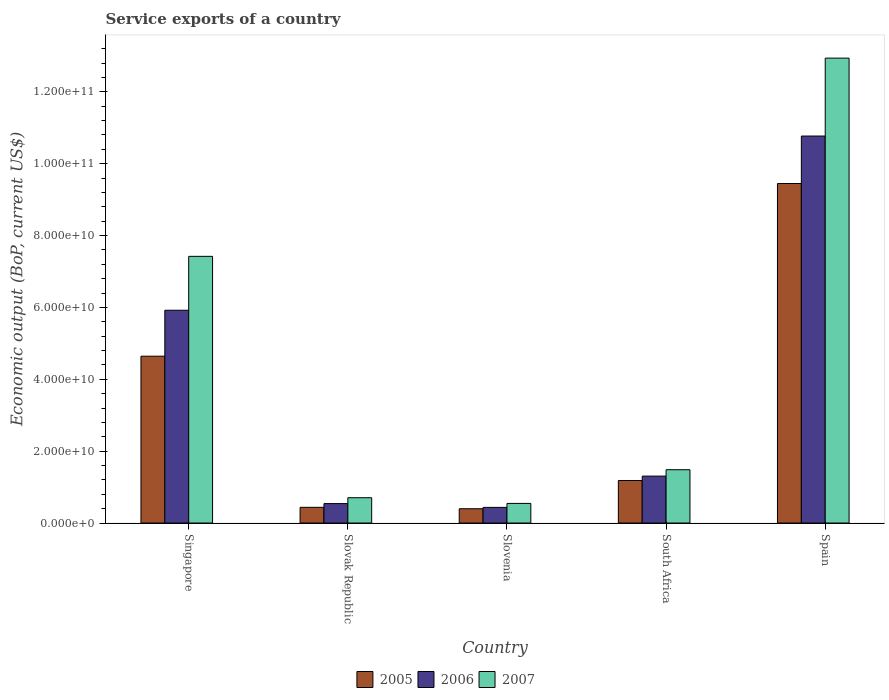How many groups of bars are there?
Provide a short and direct response. 5. Are the number of bars per tick equal to the number of legend labels?
Ensure brevity in your answer.  Yes. How many bars are there on the 5th tick from the left?
Your answer should be compact. 3. How many bars are there on the 1st tick from the right?
Provide a short and direct response. 3. What is the label of the 1st group of bars from the left?
Your response must be concise. Singapore. What is the service exports in 2005 in Slovak Republic?
Your answer should be very brief. 4.37e+09. Across all countries, what is the maximum service exports in 2007?
Make the answer very short. 1.29e+11. Across all countries, what is the minimum service exports in 2007?
Offer a terse response. 5.46e+09. In which country was the service exports in 2007 minimum?
Your answer should be compact. Slovenia. What is the total service exports in 2005 in the graph?
Your answer should be compact. 1.61e+11. What is the difference between the service exports in 2006 in Singapore and that in Slovak Republic?
Ensure brevity in your answer.  5.38e+1. What is the difference between the service exports in 2006 in Slovenia and the service exports in 2005 in Slovak Republic?
Your response must be concise. -1.58e+07. What is the average service exports in 2007 per country?
Offer a very short reply. 4.62e+1. What is the difference between the service exports of/in 2005 and service exports of/in 2007 in Slovak Republic?
Your response must be concise. -2.67e+09. What is the ratio of the service exports in 2007 in Singapore to that in South Africa?
Offer a terse response. 5. Is the service exports in 2005 in Slovak Republic less than that in South Africa?
Ensure brevity in your answer.  Yes. Is the difference between the service exports in 2005 in Slovak Republic and Slovenia greater than the difference between the service exports in 2007 in Slovak Republic and Slovenia?
Make the answer very short. No. What is the difference between the highest and the second highest service exports in 2007?
Provide a short and direct response. 5.52e+1. What is the difference between the highest and the lowest service exports in 2006?
Your answer should be very brief. 1.03e+11. Is the sum of the service exports in 2006 in Singapore and Slovenia greater than the maximum service exports in 2007 across all countries?
Your answer should be compact. No. What does the 3rd bar from the right in Singapore represents?
Provide a succinct answer. 2005. Is it the case that in every country, the sum of the service exports in 2005 and service exports in 2007 is greater than the service exports in 2006?
Ensure brevity in your answer.  Yes. Are all the bars in the graph horizontal?
Your response must be concise. No. How many countries are there in the graph?
Your answer should be very brief. 5. What is the difference between two consecutive major ticks on the Y-axis?
Give a very brief answer. 2.00e+1. Are the values on the major ticks of Y-axis written in scientific E-notation?
Offer a very short reply. Yes. Does the graph contain any zero values?
Give a very brief answer. No. How many legend labels are there?
Your answer should be very brief. 3. What is the title of the graph?
Offer a very short reply. Service exports of a country. What is the label or title of the Y-axis?
Your response must be concise. Economic output (BoP, current US$). What is the Economic output (BoP, current US$) of 2005 in Singapore?
Make the answer very short. 4.64e+1. What is the Economic output (BoP, current US$) of 2006 in Singapore?
Offer a very short reply. 5.92e+1. What is the Economic output (BoP, current US$) in 2007 in Singapore?
Your answer should be compact. 7.42e+1. What is the Economic output (BoP, current US$) of 2005 in Slovak Republic?
Your answer should be very brief. 4.37e+09. What is the Economic output (BoP, current US$) of 2006 in Slovak Republic?
Provide a short and direct response. 5.41e+09. What is the Economic output (BoP, current US$) of 2007 in Slovak Republic?
Provide a short and direct response. 7.04e+09. What is the Economic output (BoP, current US$) of 2005 in Slovenia?
Offer a terse response. 3.98e+09. What is the Economic output (BoP, current US$) in 2006 in Slovenia?
Offer a terse response. 4.36e+09. What is the Economic output (BoP, current US$) in 2007 in Slovenia?
Make the answer very short. 5.46e+09. What is the Economic output (BoP, current US$) in 2005 in South Africa?
Ensure brevity in your answer.  1.18e+1. What is the Economic output (BoP, current US$) of 2006 in South Africa?
Offer a very short reply. 1.31e+1. What is the Economic output (BoP, current US$) in 2007 in South Africa?
Give a very brief answer. 1.48e+1. What is the Economic output (BoP, current US$) of 2005 in Spain?
Provide a succinct answer. 9.45e+1. What is the Economic output (BoP, current US$) of 2006 in Spain?
Provide a succinct answer. 1.08e+11. What is the Economic output (BoP, current US$) of 2007 in Spain?
Your answer should be compact. 1.29e+11. Across all countries, what is the maximum Economic output (BoP, current US$) of 2005?
Make the answer very short. 9.45e+1. Across all countries, what is the maximum Economic output (BoP, current US$) in 2006?
Ensure brevity in your answer.  1.08e+11. Across all countries, what is the maximum Economic output (BoP, current US$) of 2007?
Your answer should be very brief. 1.29e+11. Across all countries, what is the minimum Economic output (BoP, current US$) of 2005?
Make the answer very short. 3.98e+09. Across all countries, what is the minimum Economic output (BoP, current US$) of 2006?
Ensure brevity in your answer.  4.36e+09. Across all countries, what is the minimum Economic output (BoP, current US$) in 2007?
Make the answer very short. 5.46e+09. What is the total Economic output (BoP, current US$) of 2005 in the graph?
Your answer should be compact. 1.61e+11. What is the total Economic output (BoP, current US$) in 2006 in the graph?
Offer a terse response. 1.90e+11. What is the total Economic output (BoP, current US$) of 2007 in the graph?
Provide a succinct answer. 2.31e+11. What is the difference between the Economic output (BoP, current US$) in 2005 in Singapore and that in Slovak Republic?
Your response must be concise. 4.21e+1. What is the difference between the Economic output (BoP, current US$) in 2006 in Singapore and that in Slovak Republic?
Make the answer very short. 5.38e+1. What is the difference between the Economic output (BoP, current US$) of 2007 in Singapore and that in Slovak Republic?
Offer a terse response. 6.72e+1. What is the difference between the Economic output (BoP, current US$) in 2005 in Singapore and that in Slovenia?
Your answer should be compact. 4.25e+1. What is the difference between the Economic output (BoP, current US$) of 2006 in Singapore and that in Slovenia?
Your answer should be compact. 5.49e+1. What is the difference between the Economic output (BoP, current US$) of 2007 in Singapore and that in Slovenia?
Your answer should be compact. 6.88e+1. What is the difference between the Economic output (BoP, current US$) of 2005 in Singapore and that in South Africa?
Offer a terse response. 3.46e+1. What is the difference between the Economic output (BoP, current US$) in 2006 in Singapore and that in South Africa?
Ensure brevity in your answer.  4.62e+1. What is the difference between the Economic output (BoP, current US$) in 2007 in Singapore and that in South Africa?
Offer a terse response. 5.94e+1. What is the difference between the Economic output (BoP, current US$) of 2005 in Singapore and that in Spain?
Offer a terse response. -4.81e+1. What is the difference between the Economic output (BoP, current US$) of 2006 in Singapore and that in Spain?
Give a very brief answer. -4.85e+1. What is the difference between the Economic output (BoP, current US$) in 2007 in Singapore and that in Spain?
Offer a very short reply. -5.52e+1. What is the difference between the Economic output (BoP, current US$) in 2005 in Slovak Republic and that in Slovenia?
Keep it short and to the point. 3.96e+08. What is the difference between the Economic output (BoP, current US$) in 2006 in Slovak Republic and that in Slovenia?
Offer a very short reply. 1.06e+09. What is the difference between the Economic output (BoP, current US$) of 2007 in Slovak Republic and that in Slovenia?
Make the answer very short. 1.59e+09. What is the difference between the Economic output (BoP, current US$) in 2005 in Slovak Republic and that in South Africa?
Keep it short and to the point. -7.46e+09. What is the difference between the Economic output (BoP, current US$) of 2006 in Slovak Republic and that in South Africa?
Give a very brief answer. -7.65e+09. What is the difference between the Economic output (BoP, current US$) of 2007 in Slovak Republic and that in South Africa?
Your response must be concise. -7.79e+09. What is the difference between the Economic output (BoP, current US$) in 2005 in Slovak Republic and that in Spain?
Offer a very short reply. -9.01e+1. What is the difference between the Economic output (BoP, current US$) of 2006 in Slovak Republic and that in Spain?
Make the answer very short. -1.02e+11. What is the difference between the Economic output (BoP, current US$) of 2007 in Slovak Republic and that in Spain?
Your answer should be compact. -1.22e+11. What is the difference between the Economic output (BoP, current US$) of 2005 in Slovenia and that in South Africa?
Provide a short and direct response. -7.85e+09. What is the difference between the Economic output (BoP, current US$) in 2006 in Slovenia and that in South Africa?
Your answer should be compact. -8.70e+09. What is the difference between the Economic output (BoP, current US$) of 2007 in Slovenia and that in South Africa?
Provide a succinct answer. -9.38e+09. What is the difference between the Economic output (BoP, current US$) in 2005 in Slovenia and that in Spain?
Your response must be concise. -9.05e+1. What is the difference between the Economic output (BoP, current US$) of 2006 in Slovenia and that in Spain?
Your response must be concise. -1.03e+11. What is the difference between the Economic output (BoP, current US$) in 2007 in Slovenia and that in Spain?
Your answer should be very brief. -1.24e+11. What is the difference between the Economic output (BoP, current US$) in 2005 in South Africa and that in Spain?
Offer a terse response. -8.27e+1. What is the difference between the Economic output (BoP, current US$) in 2006 in South Africa and that in Spain?
Offer a terse response. -9.46e+1. What is the difference between the Economic output (BoP, current US$) of 2007 in South Africa and that in Spain?
Your answer should be compact. -1.15e+11. What is the difference between the Economic output (BoP, current US$) of 2005 in Singapore and the Economic output (BoP, current US$) of 2006 in Slovak Republic?
Give a very brief answer. 4.10e+1. What is the difference between the Economic output (BoP, current US$) in 2005 in Singapore and the Economic output (BoP, current US$) in 2007 in Slovak Republic?
Make the answer very short. 3.94e+1. What is the difference between the Economic output (BoP, current US$) of 2006 in Singapore and the Economic output (BoP, current US$) of 2007 in Slovak Republic?
Ensure brevity in your answer.  5.22e+1. What is the difference between the Economic output (BoP, current US$) in 2005 in Singapore and the Economic output (BoP, current US$) in 2006 in Slovenia?
Provide a short and direct response. 4.21e+1. What is the difference between the Economic output (BoP, current US$) in 2005 in Singapore and the Economic output (BoP, current US$) in 2007 in Slovenia?
Offer a terse response. 4.10e+1. What is the difference between the Economic output (BoP, current US$) in 2006 in Singapore and the Economic output (BoP, current US$) in 2007 in Slovenia?
Provide a succinct answer. 5.38e+1. What is the difference between the Economic output (BoP, current US$) in 2005 in Singapore and the Economic output (BoP, current US$) in 2006 in South Africa?
Provide a succinct answer. 3.34e+1. What is the difference between the Economic output (BoP, current US$) in 2005 in Singapore and the Economic output (BoP, current US$) in 2007 in South Africa?
Make the answer very short. 3.16e+1. What is the difference between the Economic output (BoP, current US$) of 2006 in Singapore and the Economic output (BoP, current US$) of 2007 in South Africa?
Your response must be concise. 4.44e+1. What is the difference between the Economic output (BoP, current US$) in 2005 in Singapore and the Economic output (BoP, current US$) in 2006 in Spain?
Your response must be concise. -6.13e+1. What is the difference between the Economic output (BoP, current US$) in 2005 in Singapore and the Economic output (BoP, current US$) in 2007 in Spain?
Keep it short and to the point. -8.30e+1. What is the difference between the Economic output (BoP, current US$) of 2006 in Singapore and the Economic output (BoP, current US$) of 2007 in Spain?
Give a very brief answer. -7.02e+1. What is the difference between the Economic output (BoP, current US$) in 2005 in Slovak Republic and the Economic output (BoP, current US$) in 2006 in Slovenia?
Your answer should be compact. 1.58e+07. What is the difference between the Economic output (BoP, current US$) of 2005 in Slovak Republic and the Economic output (BoP, current US$) of 2007 in Slovenia?
Give a very brief answer. -1.09e+09. What is the difference between the Economic output (BoP, current US$) of 2006 in Slovak Republic and the Economic output (BoP, current US$) of 2007 in Slovenia?
Make the answer very short. -4.57e+07. What is the difference between the Economic output (BoP, current US$) of 2005 in Slovak Republic and the Economic output (BoP, current US$) of 2006 in South Africa?
Your answer should be compact. -8.69e+09. What is the difference between the Economic output (BoP, current US$) in 2005 in Slovak Republic and the Economic output (BoP, current US$) in 2007 in South Africa?
Offer a very short reply. -1.05e+1. What is the difference between the Economic output (BoP, current US$) in 2006 in Slovak Republic and the Economic output (BoP, current US$) in 2007 in South Africa?
Give a very brief answer. -9.43e+09. What is the difference between the Economic output (BoP, current US$) of 2005 in Slovak Republic and the Economic output (BoP, current US$) of 2006 in Spain?
Keep it short and to the point. -1.03e+11. What is the difference between the Economic output (BoP, current US$) of 2005 in Slovak Republic and the Economic output (BoP, current US$) of 2007 in Spain?
Offer a very short reply. -1.25e+11. What is the difference between the Economic output (BoP, current US$) of 2006 in Slovak Republic and the Economic output (BoP, current US$) of 2007 in Spain?
Your response must be concise. -1.24e+11. What is the difference between the Economic output (BoP, current US$) in 2005 in Slovenia and the Economic output (BoP, current US$) in 2006 in South Africa?
Ensure brevity in your answer.  -9.08e+09. What is the difference between the Economic output (BoP, current US$) of 2005 in Slovenia and the Economic output (BoP, current US$) of 2007 in South Africa?
Your response must be concise. -1.09e+1. What is the difference between the Economic output (BoP, current US$) in 2006 in Slovenia and the Economic output (BoP, current US$) in 2007 in South Africa?
Provide a short and direct response. -1.05e+1. What is the difference between the Economic output (BoP, current US$) of 2005 in Slovenia and the Economic output (BoP, current US$) of 2006 in Spain?
Provide a short and direct response. -1.04e+11. What is the difference between the Economic output (BoP, current US$) in 2005 in Slovenia and the Economic output (BoP, current US$) in 2007 in Spain?
Your answer should be very brief. -1.25e+11. What is the difference between the Economic output (BoP, current US$) of 2006 in Slovenia and the Economic output (BoP, current US$) of 2007 in Spain?
Ensure brevity in your answer.  -1.25e+11. What is the difference between the Economic output (BoP, current US$) of 2005 in South Africa and the Economic output (BoP, current US$) of 2006 in Spain?
Your answer should be very brief. -9.59e+1. What is the difference between the Economic output (BoP, current US$) in 2005 in South Africa and the Economic output (BoP, current US$) in 2007 in Spain?
Your response must be concise. -1.18e+11. What is the difference between the Economic output (BoP, current US$) in 2006 in South Africa and the Economic output (BoP, current US$) in 2007 in Spain?
Your answer should be compact. -1.16e+11. What is the average Economic output (BoP, current US$) of 2005 per country?
Provide a short and direct response. 3.22e+1. What is the average Economic output (BoP, current US$) of 2006 per country?
Make the answer very short. 3.79e+1. What is the average Economic output (BoP, current US$) in 2007 per country?
Offer a very short reply. 4.62e+1. What is the difference between the Economic output (BoP, current US$) of 2005 and Economic output (BoP, current US$) of 2006 in Singapore?
Your answer should be very brief. -1.28e+1. What is the difference between the Economic output (BoP, current US$) in 2005 and Economic output (BoP, current US$) in 2007 in Singapore?
Provide a short and direct response. -2.78e+1. What is the difference between the Economic output (BoP, current US$) of 2006 and Economic output (BoP, current US$) of 2007 in Singapore?
Make the answer very short. -1.50e+1. What is the difference between the Economic output (BoP, current US$) of 2005 and Economic output (BoP, current US$) of 2006 in Slovak Republic?
Make the answer very short. -1.04e+09. What is the difference between the Economic output (BoP, current US$) of 2005 and Economic output (BoP, current US$) of 2007 in Slovak Republic?
Ensure brevity in your answer.  -2.67e+09. What is the difference between the Economic output (BoP, current US$) in 2006 and Economic output (BoP, current US$) in 2007 in Slovak Republic?
Your answer should be very brief. -1.63e+09. What is the difference between the Economic output (BoP, current US$) of 2005 and Economic output (BoP, current US$) of 2006 in Slovenia?
Your answer should be compact. -3.81e+08. What is the difference between the Economic output (BoP, current US$) of 2005 and Economic output (BoP, current US$) of 2007 in Slovenia?
Your answer should be very brief. -1.48e+09. What is the difference between the Economic output (BoP, current US$) in 2006 and Economic output (BoP, current US$) in 2007 in Slovenia?
Your response must be concise. -1.10e+09. What is the difference between the Economic output (BoP, current US$) in 2005 and Economic output (BoP, current US$) in 2006 in South Africa?
Your answer should be compact. -1.23e+09. What is the difference between the Economic output (BoP, current US$) in 2005 and Economic output (BoP, current US$) in 2007 in South Africa?
Your answer should be compact. -3.01e+09. What is the difference between the Economic output (BoP, current US$) in 2006 and Economic output (BoP, current US$) in 2007 in South Africa?
Your answer should be very brief. -1.78e+09. What is the difference between the Economic output (BoP, current US$) of 2005 and Economic output (BoP, current US$) of 2006 in Spain?
Keep it short and to the point. -1.32e+1. What is the difference between the Economic output (BoP, current US$) in 2005 and Economic output (BoP, current US$) in 2007 in Spain?
Provide a succinct answer. -3.49e+1. What is the difference between the Economic output (BoP, current US$) of 2006 and Economic output (BoP, current US$) of 2007 in Spain?
Your answer should be very brief. -2.17e+1. What is the ratio of the Economic output (BoP, current US$) of 2005 in Singapore to that in Slovak Republic?
Your response must be concise. 10.62. What is the ratio of the Economic output (BoP, current US$) of 2006 in Singapore to that in Slovak Republic?
Ensure brevity in your answer.  10.94. What is the ratio of the Economic output (BoP, current US$) of 2007 in Singapore to that in Slovak Republic?
Offer a very short reply. 10.53. What is the ratio of the Economic output (BoP, current US$) in 2005 in Singapore to that in Slovenia?
Provide a succinct answer. 11.68. What is the ratio of the Economic output (BoP, current US$) of 2006 in Singapore to that in Slovenia?
Provide a succinct answer. 13.59. What is the ratio of the Economic output (BoP, current US$) in 2007 in Singapore to that in Slovenia?
Your answer should be compact. 13.6. What is the ratio of the Economic output (BoP, current US$) of 2005 in Singapore to that in South Africa?
Your answer should be compact. 3.92. What is the ratio of the Economic output (BoP, current US$) of 2006 in Singapore to that in South Africa?
Your answer should be compact. 4.53. What is the ratio of the Economic output (BoP, current US$) of 2007 in Singapore to that in South Africa?
Provide a succinct answer. 5. What is the ratio of the Economic output (BoP, current US$) in 2005 in Singapore to that in Spain?
Your response must be concise. 0.49. What is the ratio of the Economic output (BoP, current US$) in 2006 in Singapore to that in Spain?
Give a very brief answer. 0.55. What is the ratio of the Economic output (BoP, current US$) in 2007 in Singapore to that in Spain?
Your answer should be very brief. 0.57. What is the ratio of the Economic output (BoP, current US$) of 2005 in Slovak Republic to that in Slovenia?
Give a very brief answer. 1.1. What is the ratio of the Economic output (BoP, current US$) of 2006 in Slovak Republic to that in Slovenia?
Provide a succinct answer. 1.24. What is the ratio of the Economic output (BoP, current US$) of 2007 in Slovak Republic to that in Slovenia?
Your answer should be compact. 1.29. What is the ratio of the Economic output (BoP, current US$) in 2005 in Slovak Republic to that in South Africa?
Give a very brief answer. 0.37. What is the ratio of the Economic output (BoP, current US$) in 2006 in Slovak Republic to that in South Africa?
Ensure brevity in your answer.  0.41. What is the ratio of the Economic output (BoP, current US$) of 2007 in Slovak Republic to that in South Africa?
Offer a terse response. 0.47. What is the ratio of the Economic output (BoP, current US$) in 2005 in Slovak Republic to that in Spain?
Give a very brief answer. 0.05. What is the ratio of the Economic output (BoP, current US$) of 2006 in Slovak Republic to that in Spain?
Your answer should be very brief. 0.05. What is the ratio of the Economic output (BoP, current US$) in 2007 in Slovak Republic to that in Spain?
Keep it short and to the point. 0.05. What is the ratio of the Economic output (BoP, current US$) of 2005 in Slovenia to that in South Africa?
Give a very brief answer. 0.34. What is the ratio of the Economic output (BoP, current US$) of 2006 in Slovenia to that in South Africa?
Offer a terse response. 0.33. What is the ratio of the Economic output (BoP, current US$) of 2007 in Slovenia to that in South Africa?
Provide a short and direct response. 0.37. What is the ratio of the Economic output (BoP, current US$) in 2005 in Slovenia to that in Spain?
Provide a succinct answer. 0.04. What is the ratio of the Economic output (BoP, current US$) of 2006 in Slovenia to that in Spain?
Offer a very short reply. 0.04. What is the ratio of the Economic output (BoP, current US$) in 2007 in Slovenia to that in Spain?
Provide a short and direct response. 0.04. What is the ratio of the Economic output (BoP, current US$) in 2005 in South Africa to that in Spain?
Keep it short and to the point. 0.13. What is the ratio of the Economic output (BoP, current US$) in 2006 in South Africa to that in Spain?
Give a very brief answer. 0.12. What is the ratio of the Economic output (BoP, current US$) in 2007 in South Africa to that in Spain?
Provide a short and direct response. 0.11. What is the difference between the highest and the second highest Economic output (BoP, current US$) in 2005?
Offer a very short reply. 4.81e+1. What is the difference between the highest and the second highest Economic output (BoP, current US$) in 2006?
Provide a succinct answer. 4.85e+1. What is the difference between the highest and the second highest Economic output (BoP, current US$) of 2007?
Your answer should be very brief. 5.52e+1. What is the difference between the highest and the lowest Economic output (BoP, current US$) of 2005?
Give a very brief answer. 9.05e+1. What is the difference between the highest and the lowest Economic output (BoP, current US$) of 2006?
Keep it short and to the point. 1.03e+11. What is the difference between the highest and the lowest Economic output (BoP, current US$) of 2007?
Provide a succinct answer. 1.24e+11. 